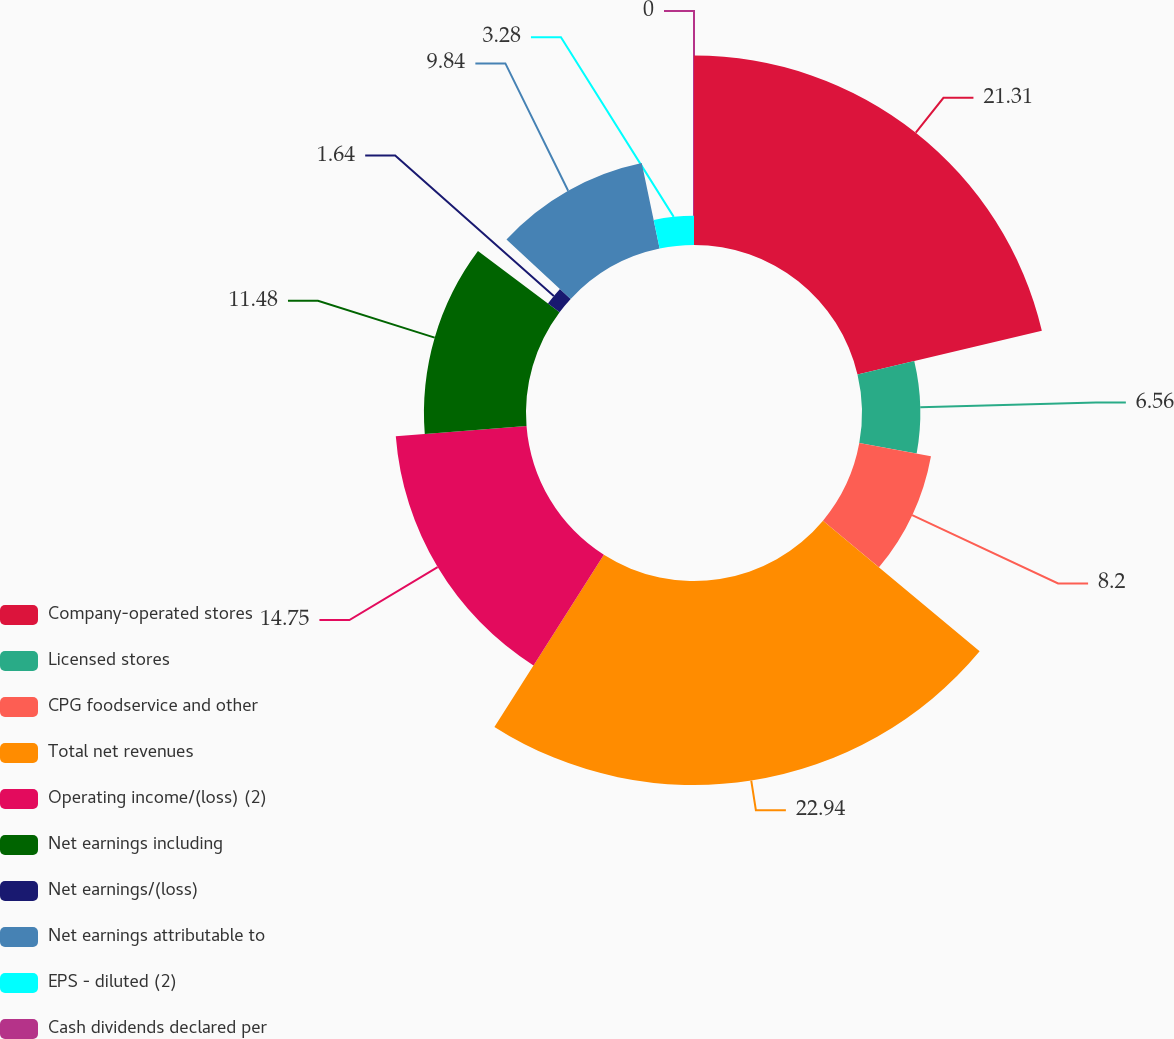<chart> <loc_0><loc_0><loc_500><loc_500><pie_chart><fcel>Company-operated stores<fcel>Licensed stores<fcel>CPG foodservice and other<fcel>Total net revenues<fcel>Operating income/(loss) (2)<fcel>Net earnings including<fcel>Net earnings/(loss)<fcel>Net earnings attributable to<fcel>EPS - diluted (2)<fcel>Cash dividends declared per<nl><fcel>21.31%<fcel>6.56%<fcel>8.2%<fcel>22.95%<fcel>14.75%<fcel>11.48%<fcel>1.64%<fcel>9.84%<fcel>3.28%<fcel>0.0%<nl></chart> 